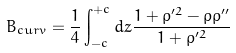<formula> <loc_0><loc_0><loc_500><loc_500>B _ { c u r v } = \frac { 1 } { 4 } \int _ { - c } ^ { + c } d z \frac { 1 + \rho ^ { \prime 2 } - \rho \rho ^ { \prime \prime } } { 1 + \rho ^ { \prime 2 } }</formula> 